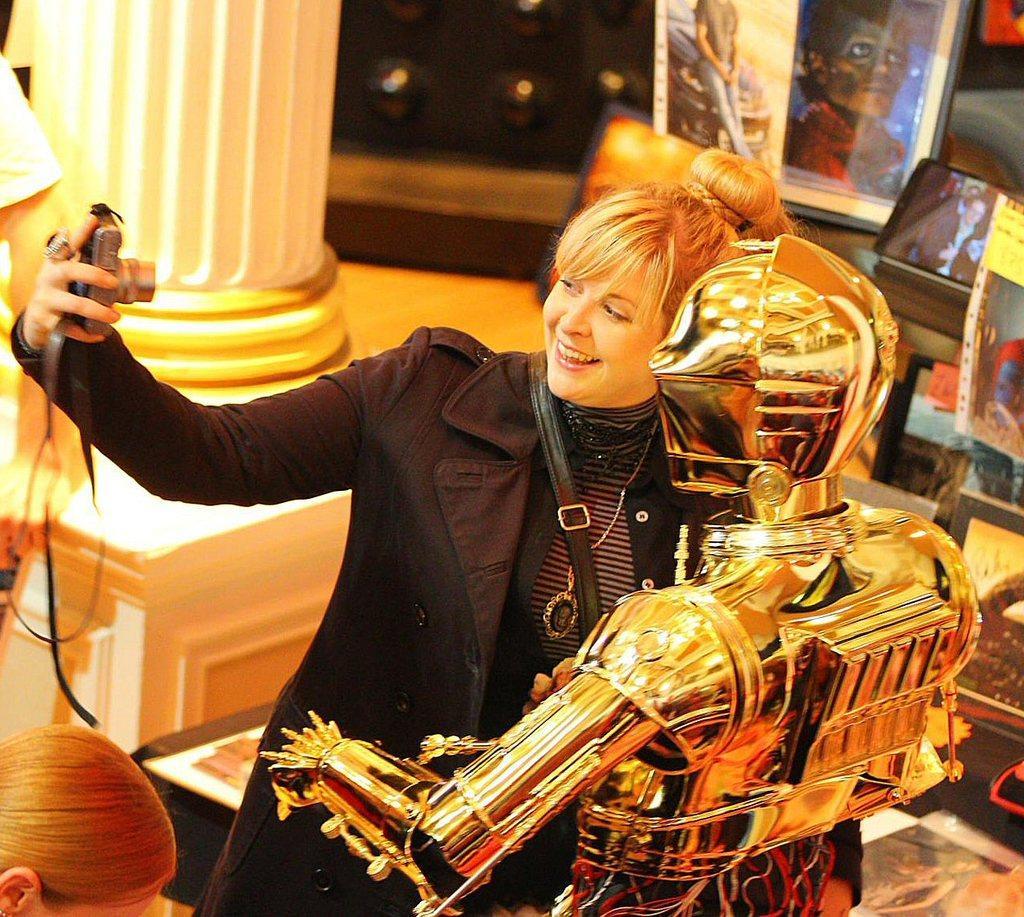Please provide a concise description of this image. In this image there is a woman holding a camera visible beside the Robert, on the left side I can see a person's head, hand, pillar, in the middle there are some hoarding, on which there are persons images. 